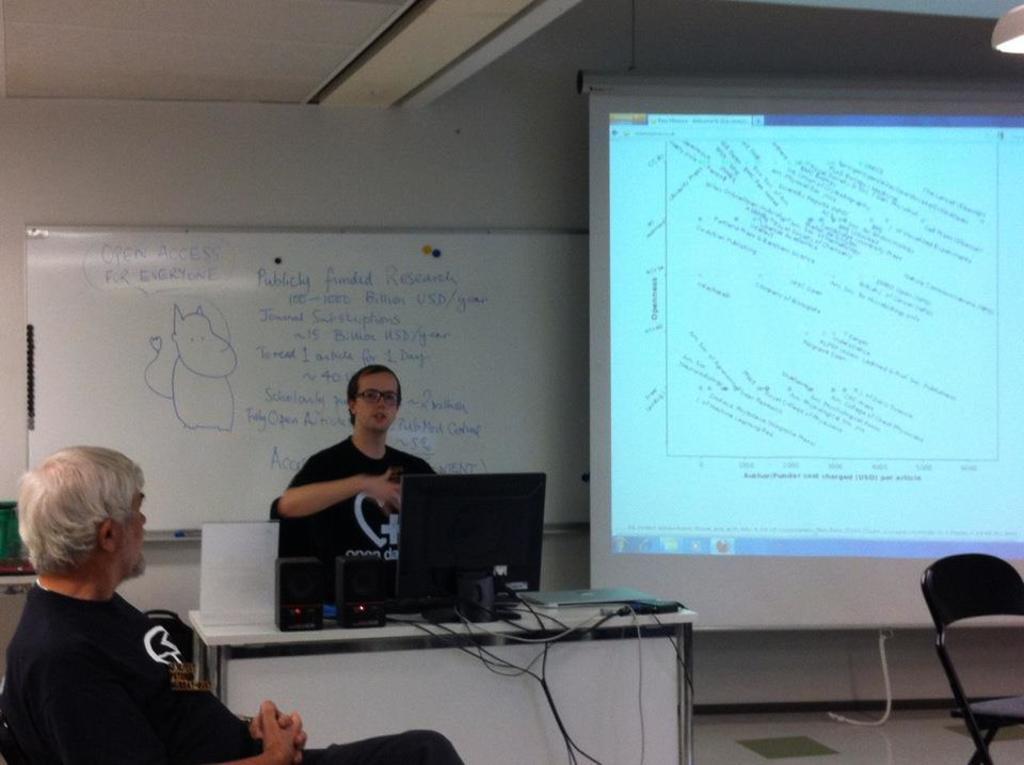In one or two sentences, can you explain what this image depicts? In the picture we can find two men one man is sitting and one man is standing. The man who is standing is explaining something and in the background we can find a board some information written on it and just beside to it we can find a screen and opposite to it there is a chair. 